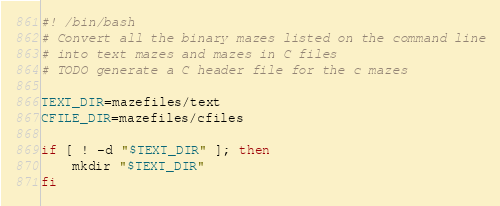Convert code to text. <code><loc_0><loc_0><loc_500><loc_500><_Bash_>#! /bin/bash
# Convert all the binary mazes listed on the command line
# into text mazes and mazes in C files
# TODO generate a C header file for the c mazes

TEXT_DIR=mazefiles/text
CFILE_DIR=mazefiles/cfiles

if [ ! -d "$TEXT_DIR" ]; then
    mkdir "$TEXT_DIR"
fi</code> 